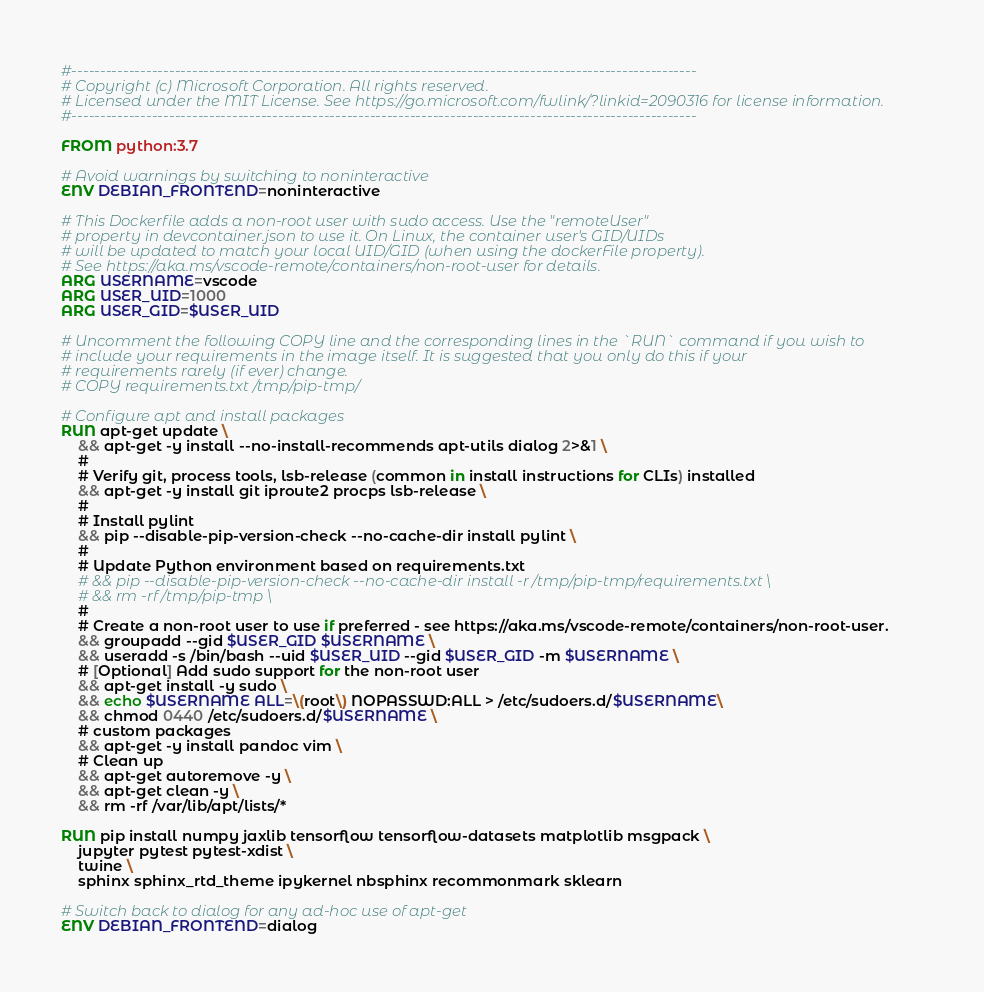<code> <loc_0><loc_0><loc_500><loc_500><_Dockerfile_>#-------------------------------------------------------------------------------------------------------------
# Copyright (c) Microsoft Corporation. All rights reserved.
# Licensed under the MIT License. See https://go.microsoft.com/fwlink/?linkid=2090316 for license information.
#-------------------------------------------------------------------------------------------------------------

FROM python:3.7

# Avoid warnings by switching to noninteractive
ENV DEBIAN_FRONTEND=noninteractive

# This Dockerfile adds a non-root user with sudo access. Use the "remoteUser"
# property in devcontainer.json to use it. On Linux, the container user's GID/UIDs
# will be updated to match your local UID/GID (when using the dockerFile property).
# See https://aka.ms/vscode-remote/containers/non-root-user for details.
ARG USERNAME=vscode
ARG USER_UID=1000
ARG USER_GID=$USER_UID

# Uncomment the following COPY line and the corresponding lines in the `RUN` command if you wish to
# include your requirements in the image itself. It is suggested that you only do this if your
# requirements rarely (if ever) change.
# COPY requirements.txt /tmp/pip-tmp/

# Configure apt and install packages
RUN apt-get update \
    && apt-get -y install --no-install-recommends apt-utils dialog 2>&1 \
    #
    # Verify git, process tools, lsb-release (common in install instructions for CLIs) installed
    && apt-get -y install git iproute2 procps lsb-release \
    #
    # Install pylint
    && pip --disable-pip-version-check --no-cache-dir install pylint \
    #
    # Update Python environment based on requirements.txt
    # && pip --disable-pip-version-check --no-cache-dir install -r /tmp/pip-tmp/requirements.txt \
    # && rm -rf /tmp/pip-tmp \
    #
    # Create a non-root user to use if preferred - see https://aka.ms/vscode-remote/containers/non-root-user.
    && groupadd --gid $USER_GID $USERNAME \
    && useradd -s /bin/bash --uid $USER_UID --gid $USER_GID -m $USERNAME \
    # [Optional] Add sudo support for the non-root user
    && apt-get install -y sudo \
    && echo $USERNAME ALL=\(root\) NOPASSWD:ALL > /etc/sudoers.d/$USERNAME\
    && chmod 0440 /etc/sudoers.d/$USERNAME \
    # custom packages
    && apt-get -y install pandoc vim \
    # Clean up
    && apt-get autoremove -y \
    && apt-get clean -y \
    && rm -rf /var/lib/apt/lists/*

RUN pip install numpy jaxlib tensorflow tensorflow-datasets matplotlib msgpack \
    jupyter pytest pytest-xdist \
    twine \
    sphinx sphinx_rtd_theme ipykernel nbsphinx recommonmark sklearn

# Switch back to dialog for any ad-hoc use of apt-get
ENV DEBIAN_FRONTEND=dialog
</code> 